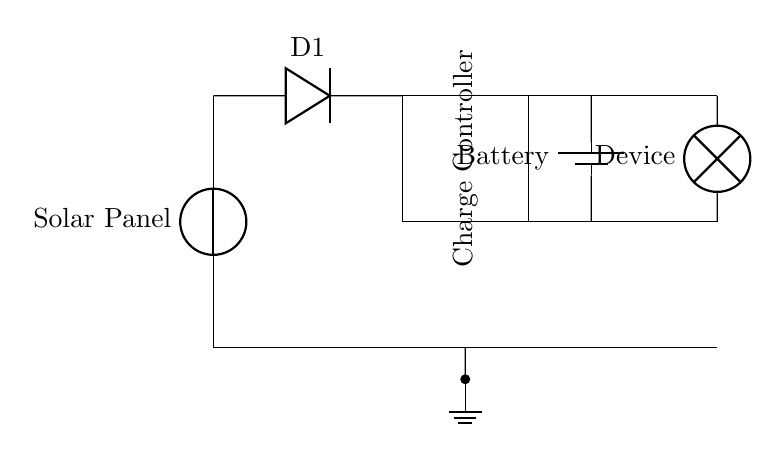What component converts solar energy into electrical energy? The component that converts solar energy into electrical energy in the circuit is the solar panel, which is represented at the start of the circuit diagram.
Answer: solar panel What is the function of diode D1? Diode D1 prevents reverse current flow, ensuring that the electricity generated by the solar panel only flows to the battery, protecting it from discharge when there is no sunlight.
Answer: prevent reverse current How many connections are shown between the charge controller and the battery? The charge controller is connected to the battery by one direct connection shown in the diagram, which illustrates how the charge controller regulates the voltage before charging the battery.
Answer: one connection What does the battery store? The battery stores electrical energy generated by the solar panel and regulated by the charge controller, enabling the power supply to small electronic devices when needed.
Answer: electrical energy What type of device is connected to the output of the battery? The device connected to the output of the battery is a small electronic device, marked as 'Device' in the circuit diagram, indicating that it consumes electrical energy supplied by the battery.
Answer: small electronic device Explain the role of the charge controller in the circuit. The charge controller regulates the flow of electricity from the solar panel to the battery, ensuring that it charges efficiently and prevents overcharging, which could damage the battery.
Answer: regulates voltage What happens if the solar panel generates insufficient energy? If the solar panel generates insufficient energy, the battery will not charge adequately, and the connected device may not receive enough power, impacting its performance or functionality.
Answer: insufficient power to device 